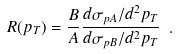<formula> <loc_0><loc_0><loc_500><loc_500>R ( p _ { T } ) = \frac { B } { A } \frac { d \sigma _ { p A } / d ^ { 2 } p _ { T } } { d \sigma _ { p B } / d ^ { 2 } p _ { T } } \ .</formula> 